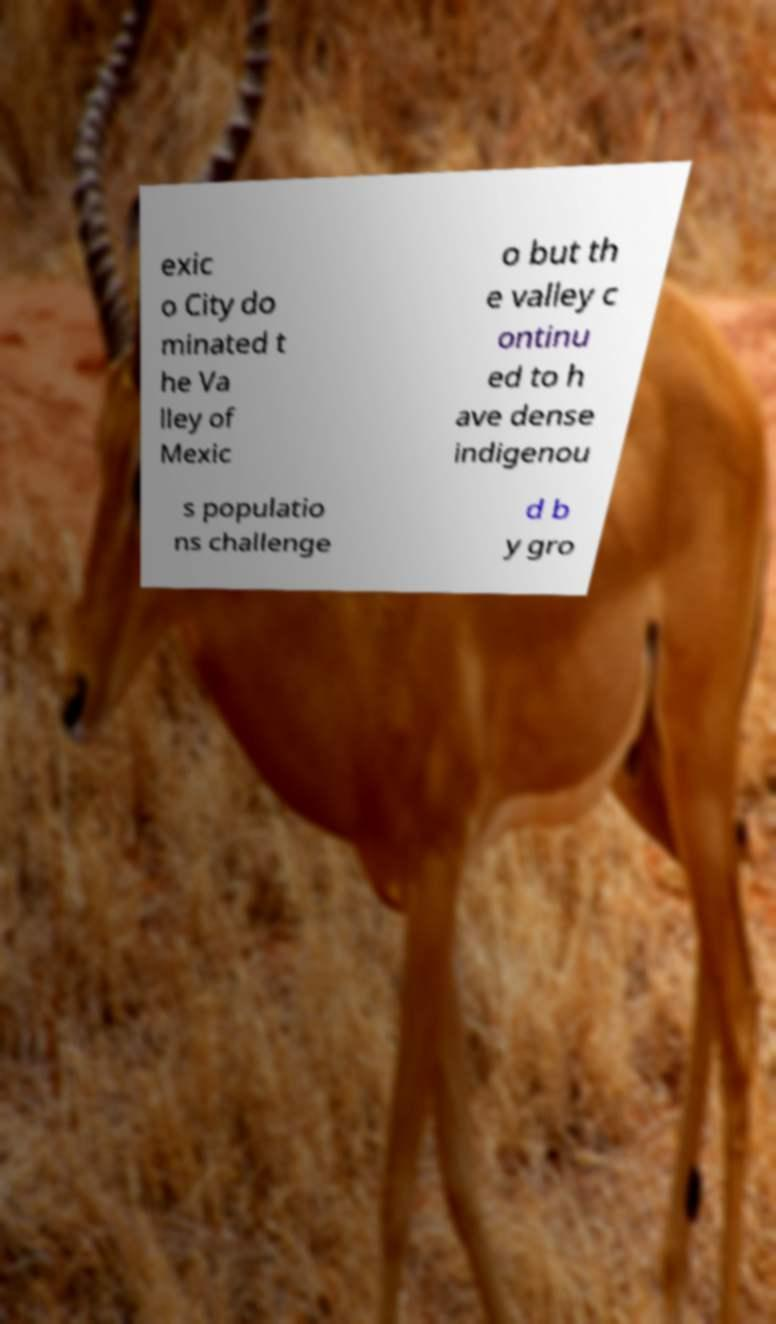Please identify and transcribe the text found in this image. exic o City do minated t he Va lley of Mexic o but th e valley c ontinu ed to h ave dense indigenou s populatio ns challenge d b y gro 